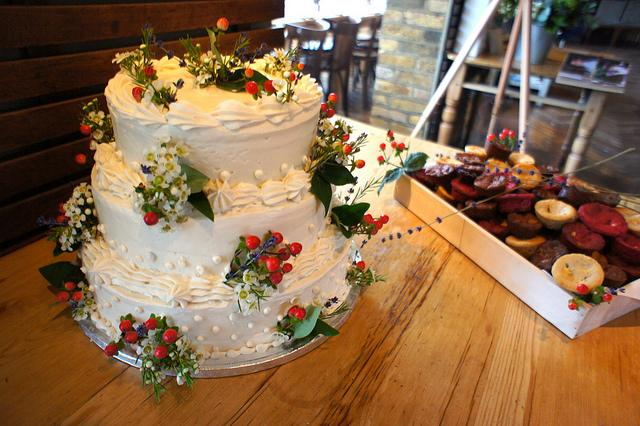Bakers usually charge by the what to make these items?

Choices:
A) hour
B) slice
C) minute
D) weight slice 